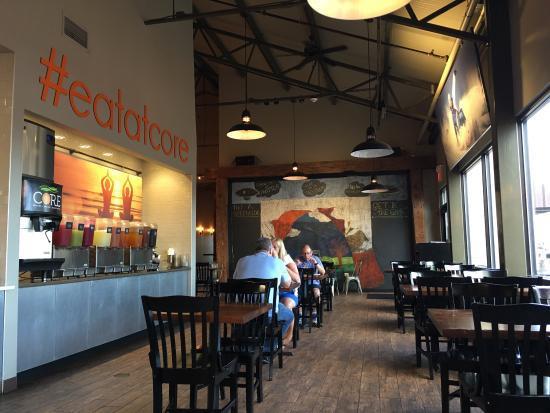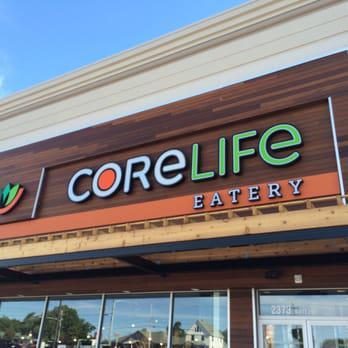The first image is the image on the left, the second image is the image on the right. Considering the images on both sides, is "The left and right image contains a total of four salads in white bowls." valid? Answer yes or no. No. The first image is the image on the left, the second image is the image on the right. Considering the images on both sides, is "The left image shows two rows of seats with an aisle of wood-grain floor between them and angled architectural elements above them on the ceiling." valid? Answer yes or no. Yes. 